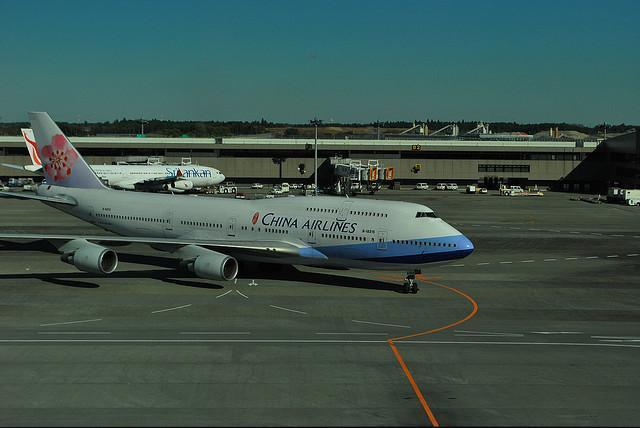How many airlines are represented in this image?
Give a very brief answer. 2. How many planes?
Give a very brief answer. 2. How many colors is the plane's tail?
Give a very brief answer. 2. How many airplanes can be seen?
Give a very brief answer. 2. How many people are in the photo?
Give a very brief answer. 0. 